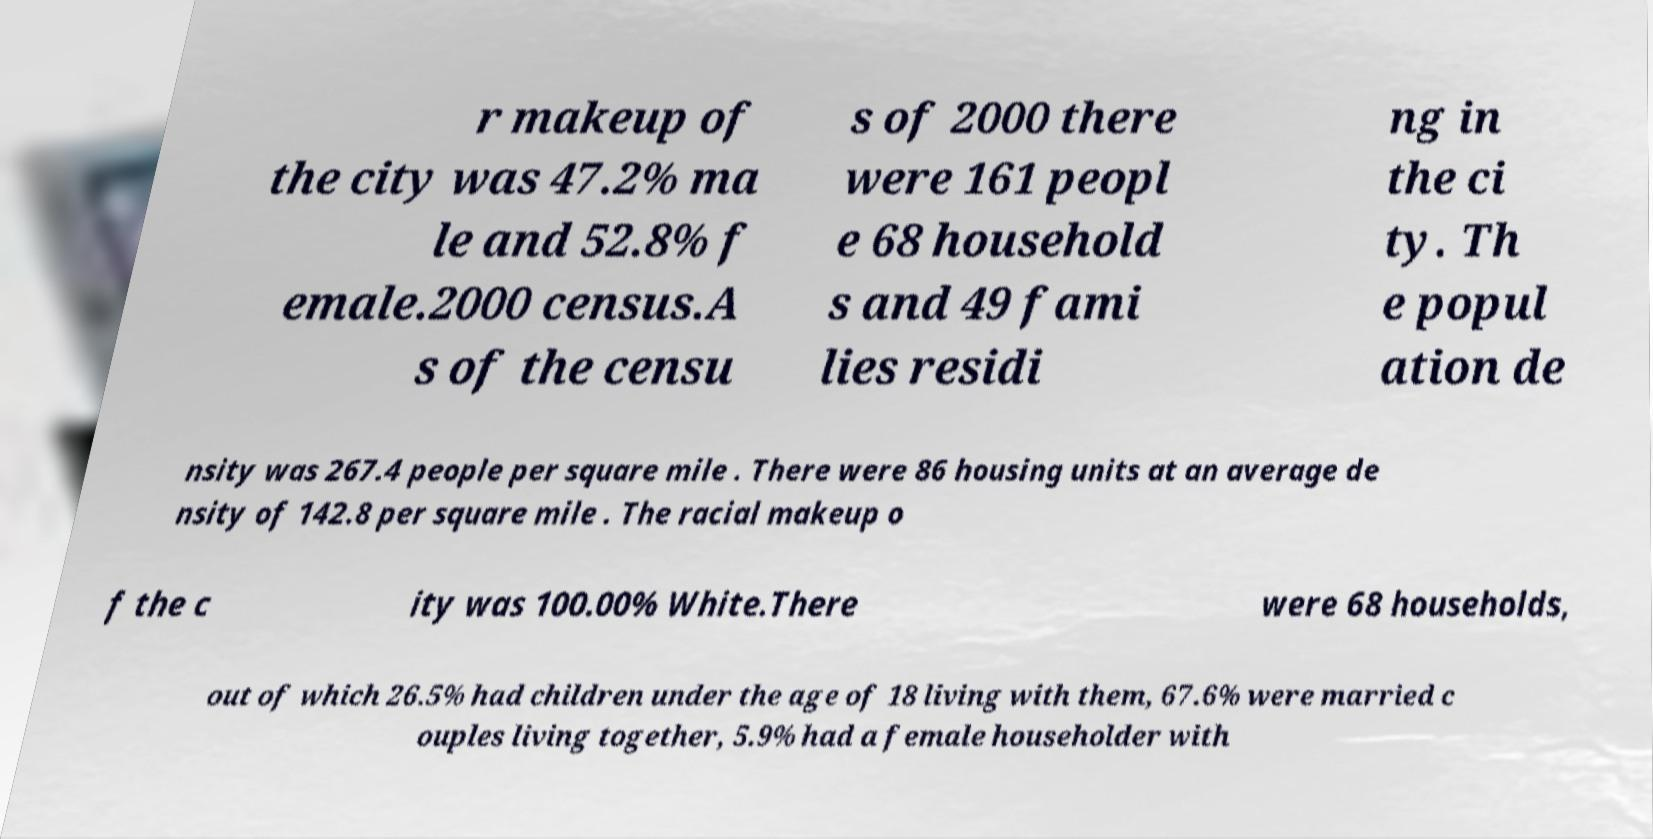Can you read and provide the text displayed in the image?This photo seems to have some interesting text. Can you extract and type it out for me? r makeup of the city was 47.2% ma le and 52.8% f emale.2000 census.A s of the censu s of 2000 there were 161 peopl e 68 household s and 49 fami lies residi ng in the ci ty. Th e popul ation de nsity was 267.4 people per square mile . There were 86 housing units at an average de nsity of 142.8 per square mile . The racial makeup o f the c ity was 100.00% White.There were 68 households, out of which 26.5% had children under the age of 18 living with them, 67.6% were married c ouples living together, 5.9% had a female householder with 